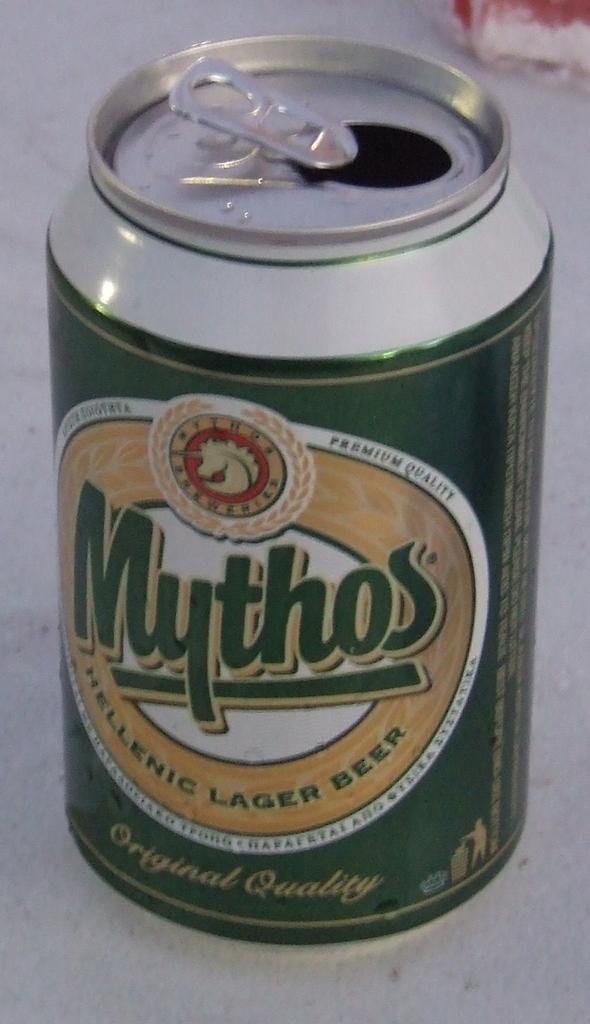What kind of lager is the beer?
Give a very brief answer. Hellenic. 